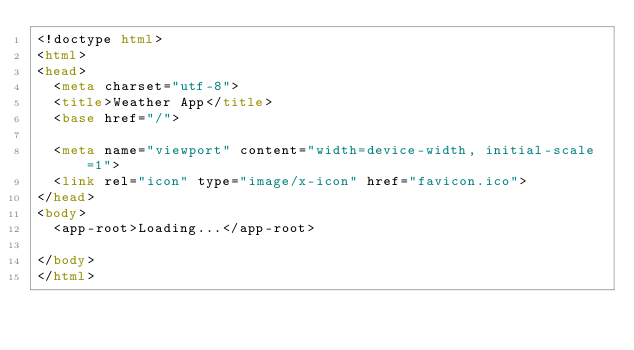Convert code to text. <code><loc_0><loc_0><loc_500><loc_500><_HTML_><!doctype html>
<html>
<head>
  <meta charset="utf-8">
  <title>Weather App</title>
  <base href="/">

  <meta name="viewport" content="width=device-width, initial-scale=1">
  <link rel="icon" type="image/x-icon" href="favicon.ico">
</head>
<body>
  <app-root>Loading...</app-root>
  
</body>
</html>
</code> 